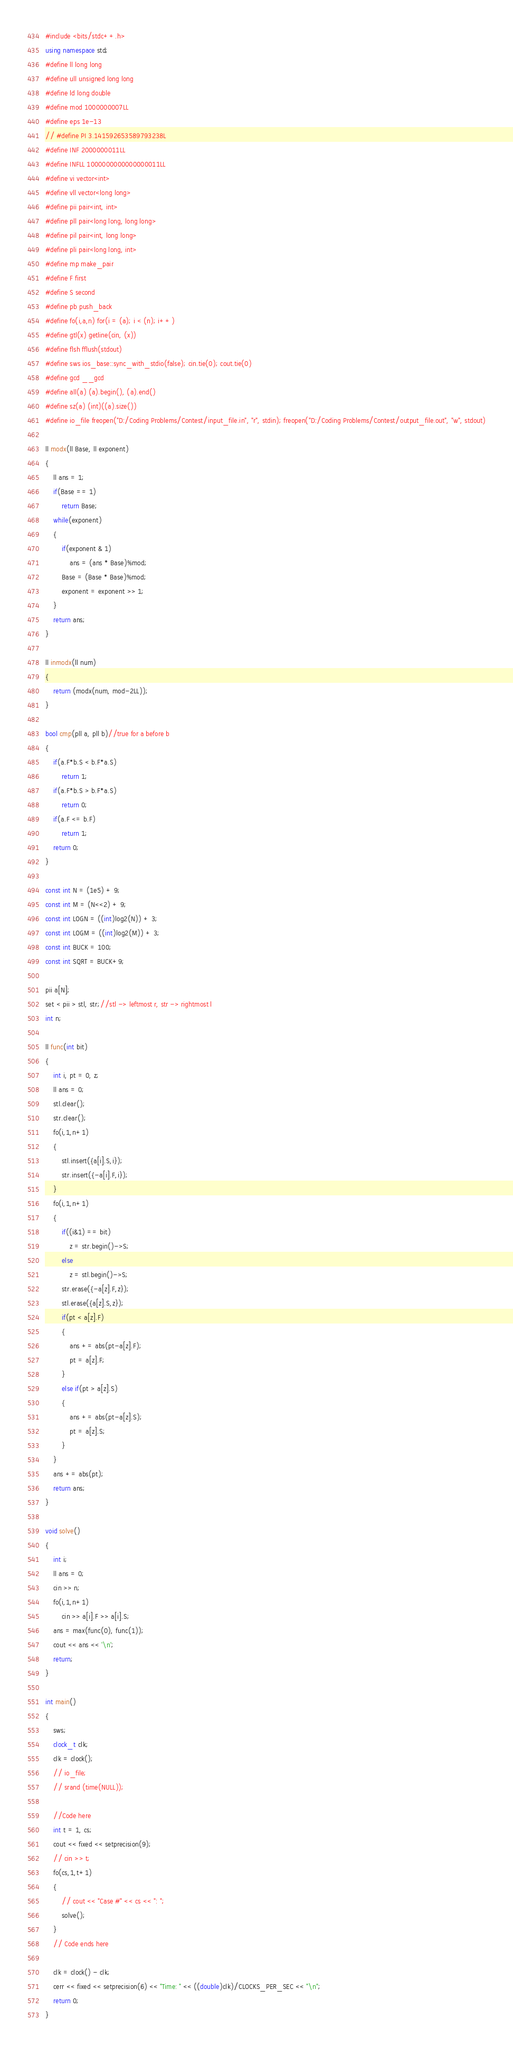<code> <loc_0><loc_0><loc_500><loc_500><_C++_>#include <bits/stdc++.h>
using namespace std;
#define ll long long
#define ull unsigned long long
#define ld long double
#define mod 1000000007LL
#define eps 1e-13
// #define PI 3.141592653589793238L
#define INF 2000000011LL
#define INFLL 1000000000000000011LL
#define vi vector<int>
#define vll vector<long long>
#define pii pair<int, int>
#define pll pair<long long, long long>
#define pil pair<int, long long>
#define pli pair<long long, int>
#define mp make_pair
#define F first
#define S second
#define pb push_back
#define fo(i,a,n) for(i = (a); i < (n); i++)
#define gtl(x) getline(cin, (x))
#define flsh fflush(stdout)
#define sws ios_base::sync_with_stdio(false); cin.tie(0); cout.tie(0)
#define gcd __gcd
#define all(a) (a).begin(), (a).end()
#define sz(a) (int)((a).size())
#define io_file freopen("D:/Coding Problems/Contest/input_file.in", "r", stdin); freopen("D:/Coding Problems/Contest/output_file.out", "w", stdout)

ll modx(ll Base, ll exponent)
{
	ll ans = 1;
	if(Base == 1)
		return Base;
	while(exponent)
	{
		if(exponent & 1)
			ans = (ans * Base)%mod;
		Base = (Base * Base)%mod;
		exponent = exponent >> 1;
	}
	return ans;
}

ll inmodx(ll num)
{
	return (modx(num, mod-2LL));
}

bool cmp(pll a, pll b)//true for a before b
{
	if(a.F*b.S < b.F*a.S)
		return 1;
	if(a.F*b.S > b.F*a.S)
		return 0;
	if(a.F <= b.F)
		return 1;
	return 0;
}

const int N = (1e5) + 9;
const int M = (N<<2) + 9;
const int LOGN = ((int)log2(N)) + 3;
const int LOGM = ((int)log2(M)) + 3;
const int BUCK = 100;
const int SQRT = BUCK+9;

pii a[N];
set < pii > stl, str;//stl -> leftmost r, str -> rightmost l
int n;

ll func(int bit)
{
	int i, pt = 0, z;
	ll ans = 0;
	stl.clear();
	str.clear();
	fo(i,1,n+1)
	{
		stl.insert({a[i].S,i});
		str.insert({-a[i].F,i});
	}
	fo(i,1,n+1)
	{
		if((i&1) == bit)
			z = str.begin()->S;
		else
			z = stl.begin()->S;
		str.erase({-a[z].F,z});
		stl.erase({a[z].S,z});
		if(pt < a[z].F)
		{
			ans += abs(pt-a[z].F);
			pt = a[z].F;
		}
		else if(pt > a[z].S)
		{
			ans += abs(pt-a[z].S);
			pt = a[z].S;
		}
	}
	ans += abs(pt);
	return ans;
}

void solve()
{
	int i;
	ll ans = 0;
	cin >> n;
	fo(i,1,n+1)
		cin >> a[i].F >> a[i].S;
	ans = max(func(0), func(1));
	cout << ans << '\n';
	return;
}

int main()
{
	sws;
	clock_t clk;
	clk = clock();
	// io_file;
	// srand (time(NULL));

	//Code here
	int t = 1, cs;
	cout << fixed << setprecision(9);
	// cin >> t;
	fo(cs,1,t+1)
	{
		// cout << "Case #" << cs << ": ";
		solve();
	}
	// Code ends here

	clk = clock() - clk;
	cerr << fixed << setprecision(6) << "Time: " << ((double)clk)/CLOCKS_PER_SEC << "\n";
	return 0;
}</code> 